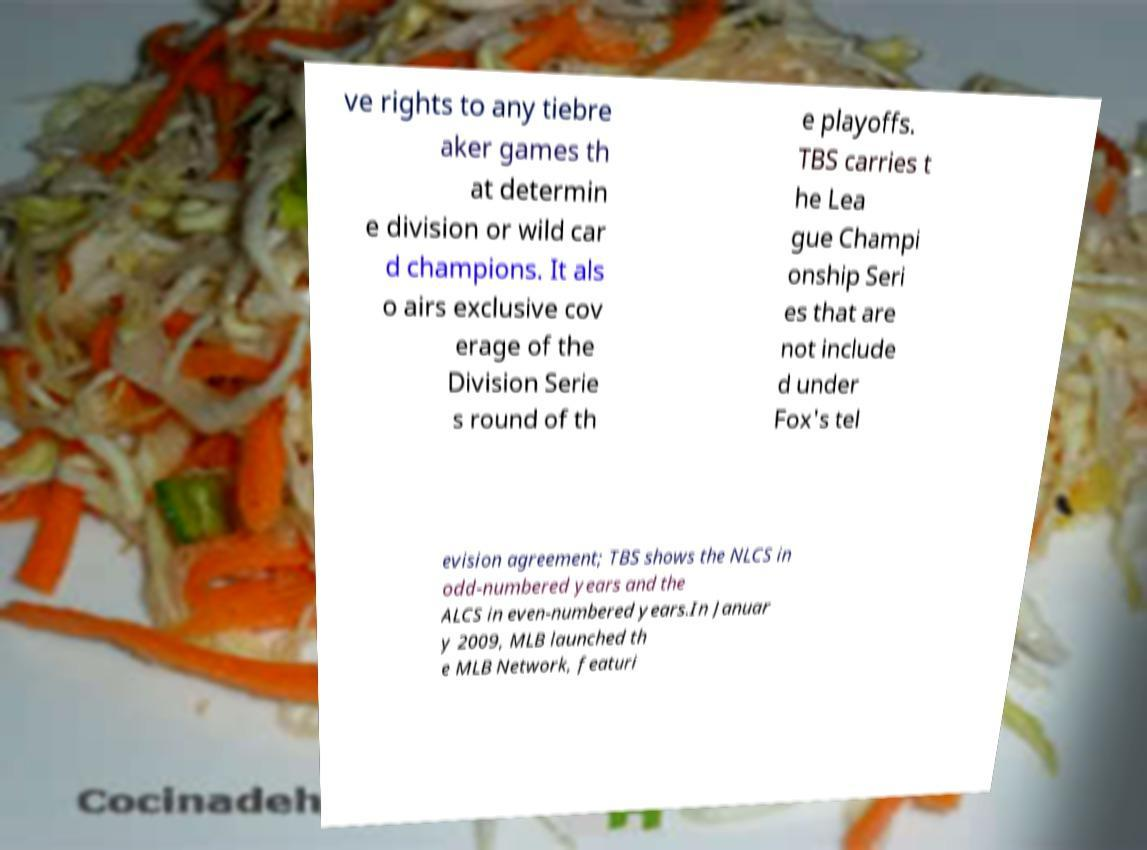There's text embedded in this image that I need extracted. Can you transcribe it verbatim? ve rights to any tiebre aker games th at determin e division or wild car d champions. It als o airs exclusive cov erage of the Division Serie s round of th e playoffs. TBS carries t he Lea gue Champi onship Seri es that are not include d under Fox's tel evision agreement; TBS shows the NLCS in odd-numbered years and the ALCS in even-numbered years.In Januar y 2009, MLB launched th e MLB Network, featuri 